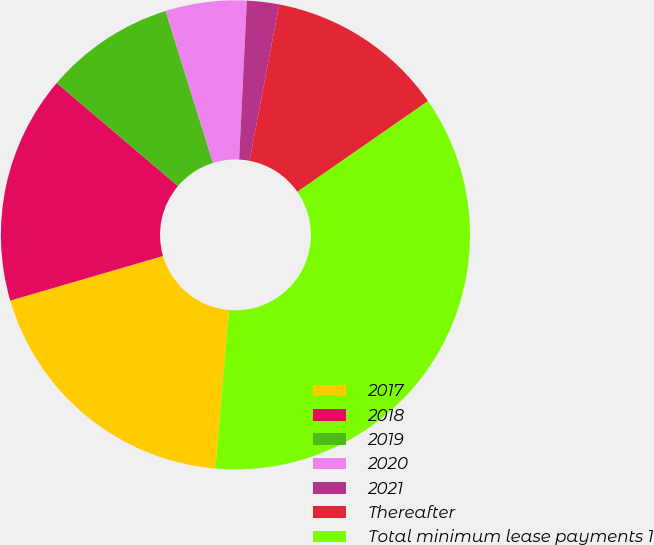<chart> <loc_0><loc_0><loc_500><loc_500><pie_chart><fcel>2017<fcel>2018<fcel>2019<fcel>2020<fcel>2021<fcel>Thereafter<fcel>Total minimum lease payments 1<nl><fcel>19.12%<fcel>15.73%<fcel>8.97%<fcel>5.59%<fcel>2.21%<fcel>12.35%<fcel>36.02%<nl></chart> 